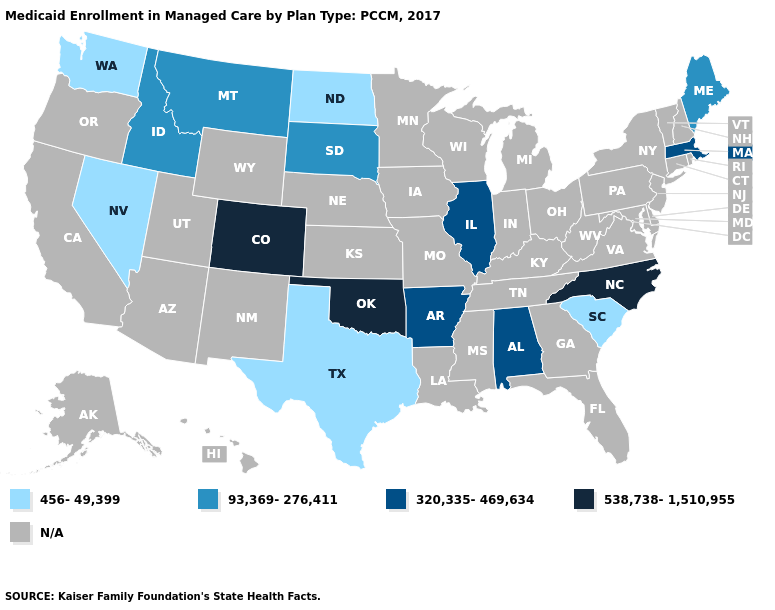Name the states that have a value in the range 320,335-469,634?
Concise answer only. Alabama, Arkansas, Illinois, Massachusetts. What is the value of Michigan?
Short answer required. N/A. What is the lowest value in states that border North Dakota?
Answer briefly. 93,369-276,411. Name the states that have a value in the range 93,369-276,411?
Quick response, please. Idaho, Maine, Montana, South Dakota. Name the states that have a value in the range 538,738-1,510,955?
Be succinct. Colorado, North Carolina, Oklahoma. What is the value of Pennsylvania?
Short answer required. N/A. Name the states that have a value in the range 320,335-469,634?
Short answer required. Alabama, Arkansas, Illinois, Massachusetts. Name the states that have a value in the range 456-49,399?
Be succinct. Nevada, North Dakota, South Carolina, Texas, Washington. How many symbols are there in the legend?
Quick response, please. 5. Among the states that border Vermont , which have the highest value?
Answer briefly. Massachusetts. What is the value of Alabama?
Concise answer only. 320,335-469,634. Does the first symbol in the legend represent the smallest category?
Answer briefly. Yes. 